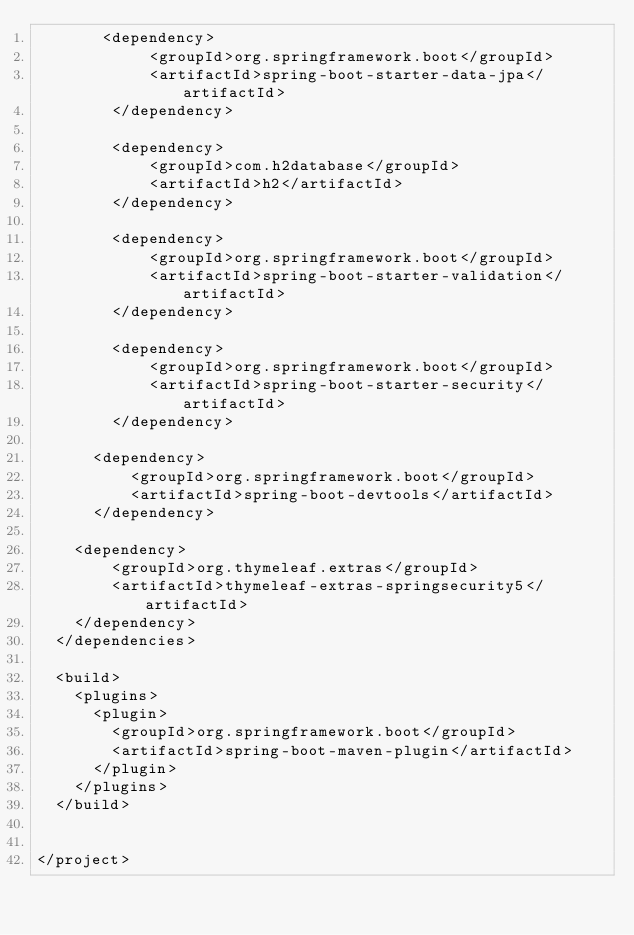<code> <loc_0><loc_0><loc_500><loc_500><_XML_>       <dependency>
            <groupId>org.springframework.boot</groupId>
            <artifactId>spring-boot-starter-data-jpa</artifactId>
        </dependency>	
        
        <dependency>
            <groupId>com.h2database</groupId>
            <artifactId>h2</artifactId>
        </dependency>        	
				
        <dependency>
            <groupId>org.springframework.boot</groupId>
            <artifactId>spring-boot-starter-validation</artifactId>
        </dependency>		
				
        <dependency>
            <groupId>org.springframework.boot</groupId>
            <artifactId>spring-boot-starter-security</artifactId>
        </dependency>		
		
	    <dependency>
	        <groupId>org.springframework.boot</groupId>
	        <artifactId>spring-boot-devtools</artifactId>
	    </dependency>
		
		<dependency>
		    <groupId>org.thymeleaf.extras</groupId>
		    <artifactId>thymeleaf-extras-springsecurity5</artifactId>
		</dependency>					        
	</dependencies>
	
	<build>
		<plugins>
			<plugin>
				<groupId>org.springframework.boot</groupId>
				<artifactId>spring-boot-maven-plugin</artifactId>
			</plugin>
		</plugins>
	</build>
	

</project>
</code> 